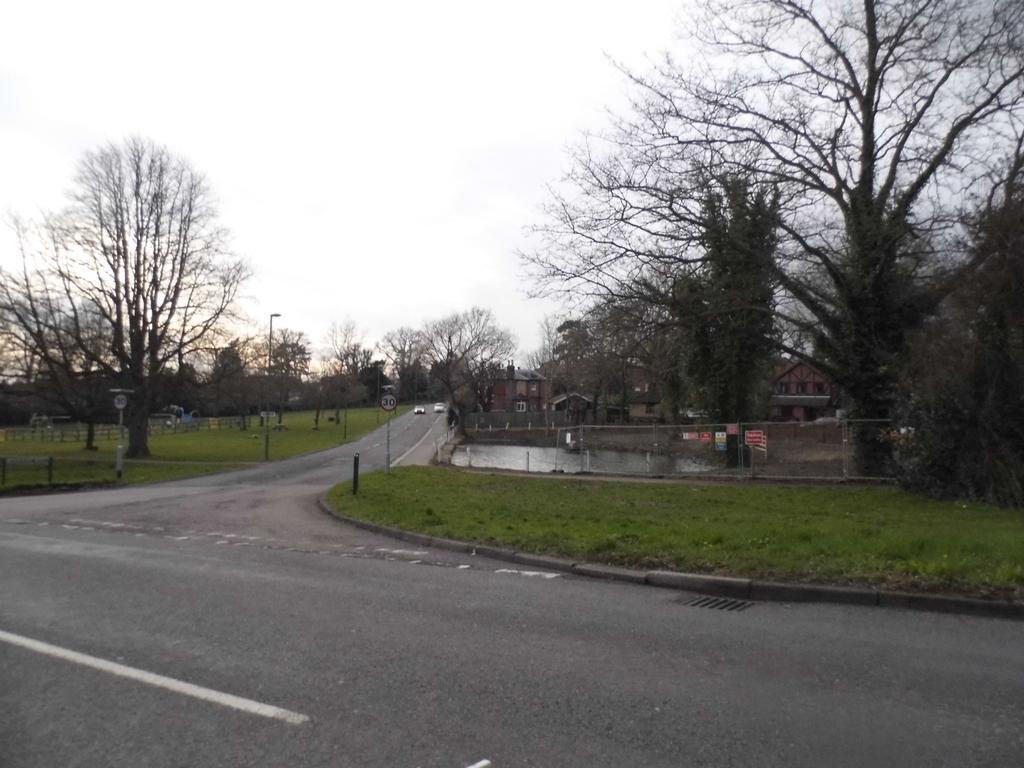Describe this image in one or two sentences. In this image, we can see vehicles on the road and in the background, there are trees, buildings, fence and at the bottom, there is ground. 